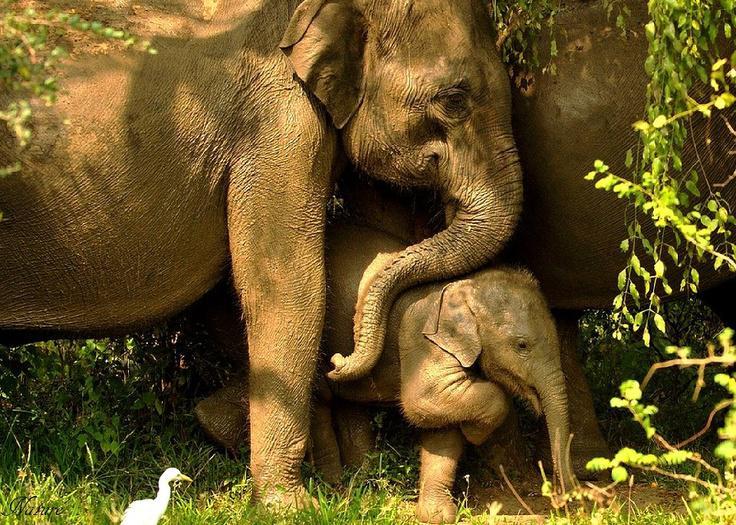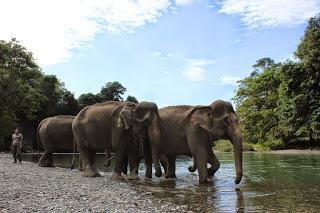The first image is the image on the left, the second image is the image on the right. Examine the images to the left and right. Is the description "An image shows at least one elephant with feet in the water." accurate? Answer yes or no. Yes. The first image is the image on the left, the second image is the image on the right. For the images displayed, is the sentence "A small white bird with a long beak appears in one image standing near at least one elephant." factually correct? Answer yes or no. Yes. 